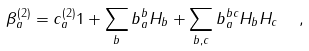Convert formula to latex. <formula><loc_0><loc_0><loc_500><loc_500>\beta _ { a } ^ { ( 2 ) } = c _ { a } ^ { ( 2 ) } { 1 } + \sum _ { b } b _ { a } ^ { b } H _ { b } + \sum _ { b , c } b _ { a } ^ { b c } H _ { b } H _ { c } \ \ ,</formula> 